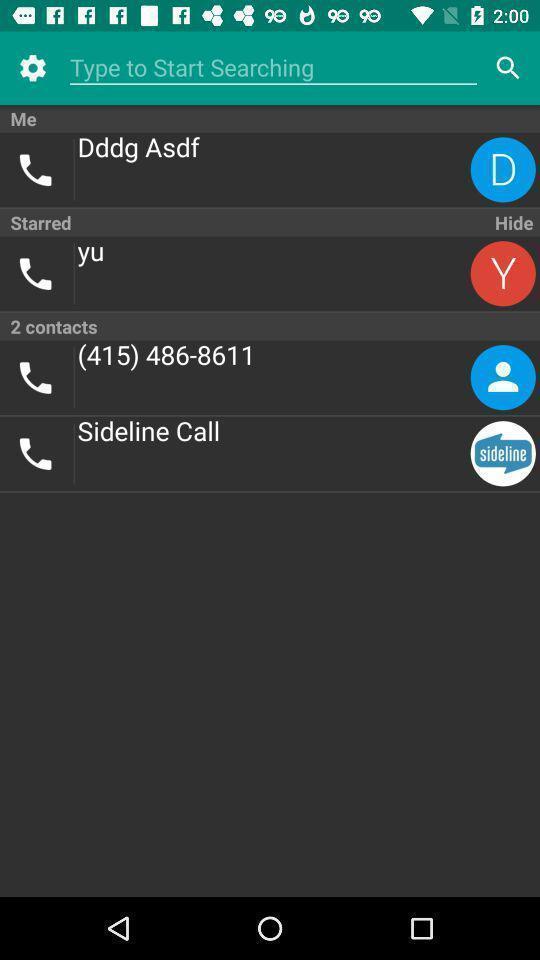Provide a description of this screenshot. Search page. 